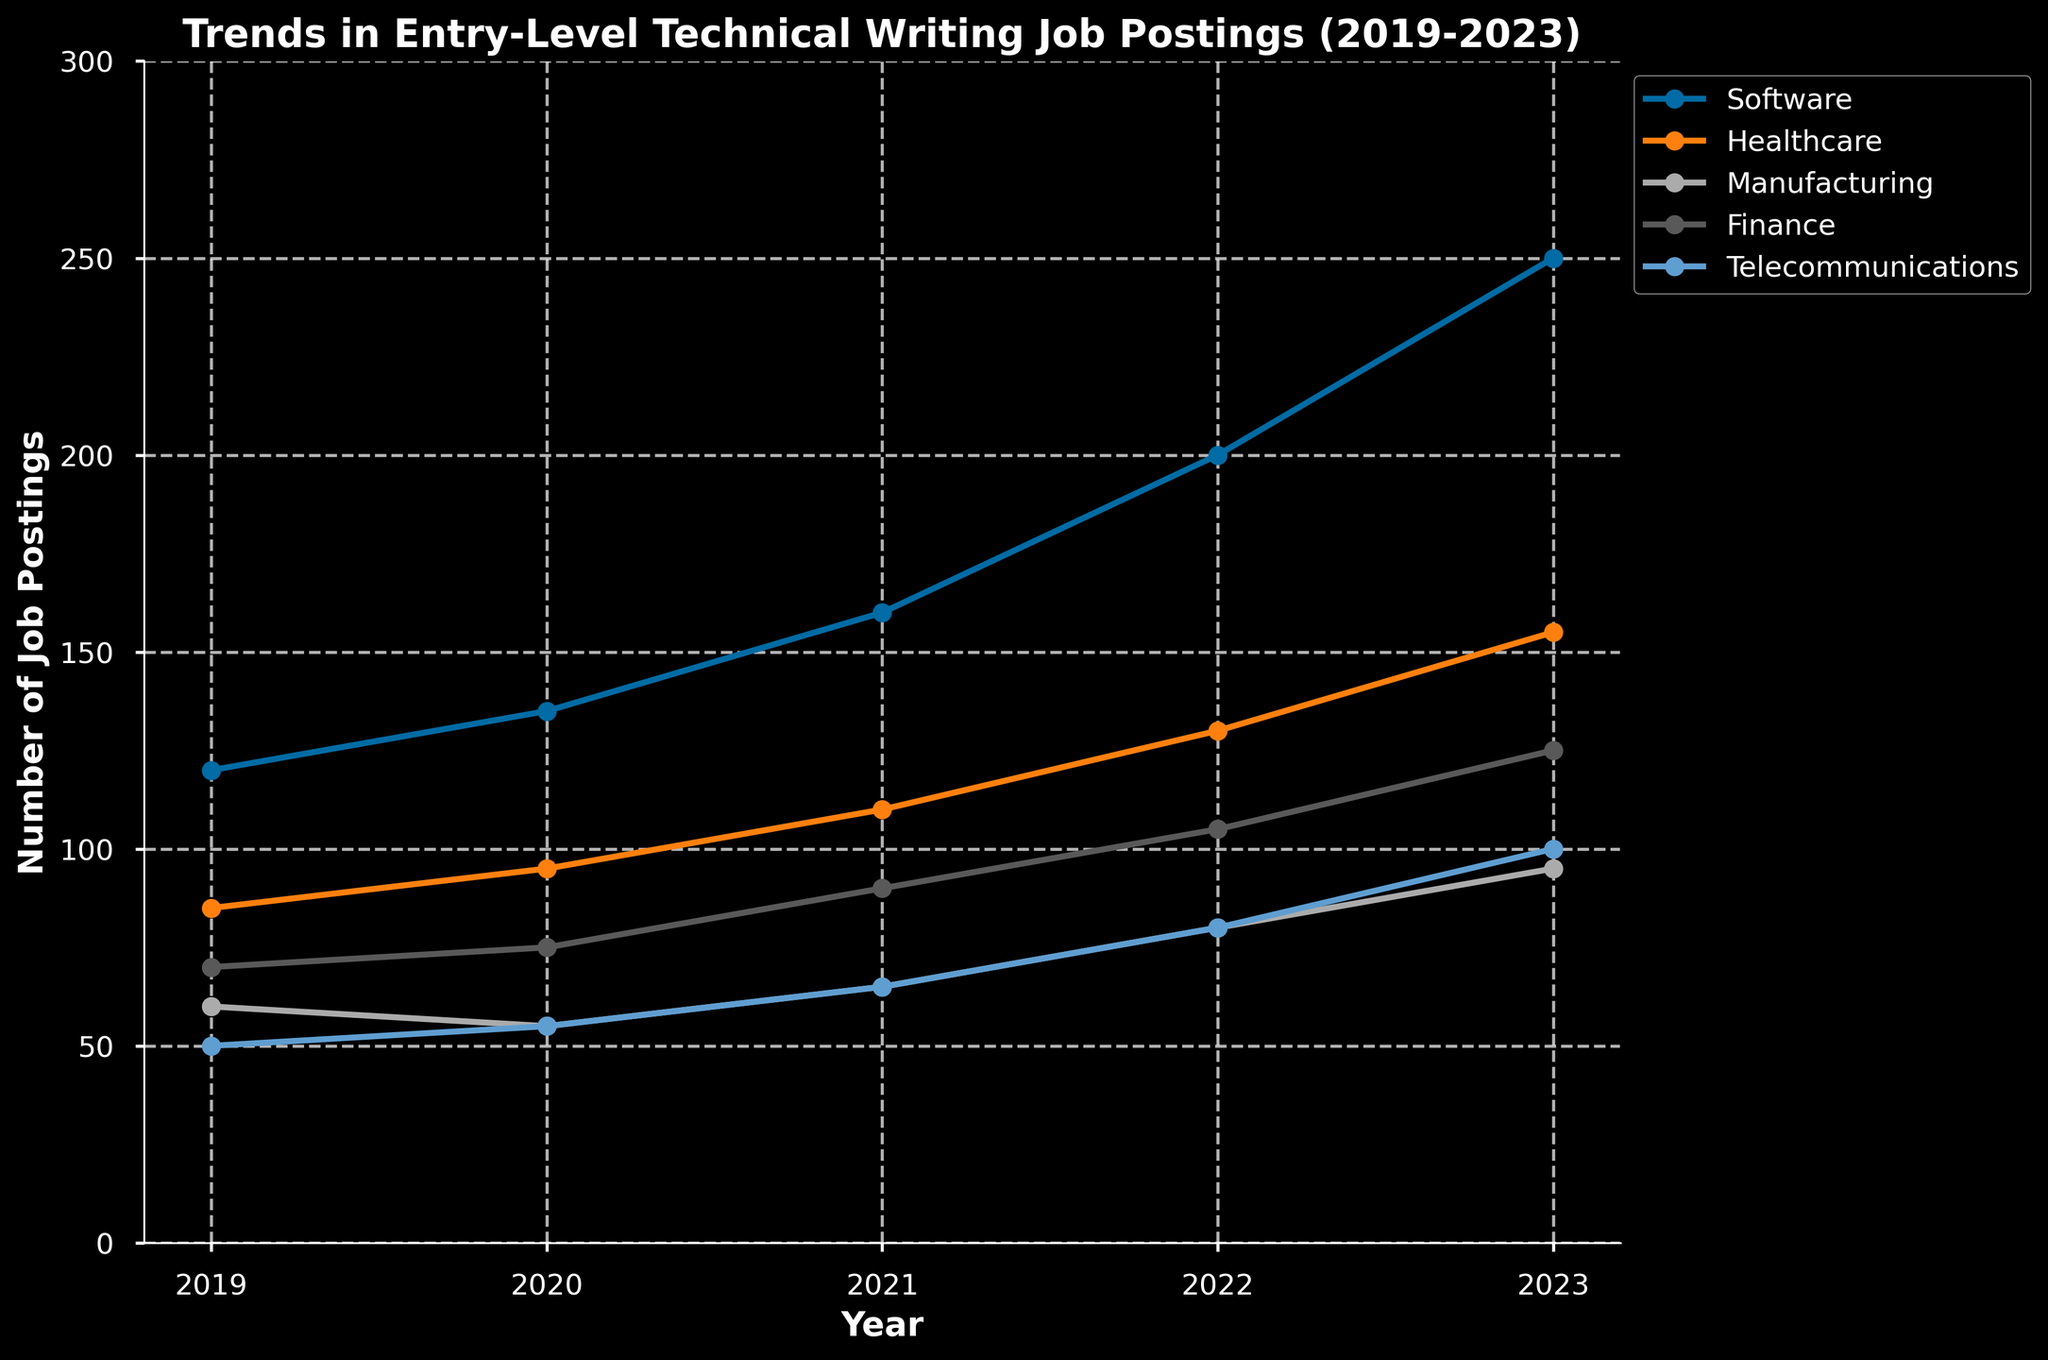What industry had the highest number of job postings in 2023? Looking at the figure, the line representing the Software industry reaches the highest point in 2023.
Answer: Software Which industry showed the most consistent growth over the 5 years? The Software industry shows a steady, consistent upward trend throughout the 5-year period. Other industries experience fluctuations.
Answer: Software How many job postings were there in total across all industries in 2021? Summing up the job postings for each industry in 2021 gives 160 (Software) + 110 (Healthcare) + 65 (Manufacturing) + 90 (Finance) + 65 (Telecommunications) = 490.
Answer: 490 What is the average number of job postings for the Manufacturing industry over the 5 years? Adding the job postings for the Manufacturing industry over 5 years (60 + 55 + 65 + 80 + 95) equals 355, and dividing by 5 gives an average of 71.
Answer: 71 In which year did Healthcare job postings surpass 100 for the first time? The figure shows Healthcare job postings exceeding 100 in 2021 for the first time (recording 110 postings).
Answer: 2021 Between 2020 and 2023, which industry had the greatest increase in job postings? Calculating the difference in job postings from 2020 to 2023: Software (250-135=115), Healthcare (155-95=60), Manufacturing (95-55=40), Finance (125-75=50), Telecommunications (100-55=45). Software had the greatest increase of 115.
Answer: Software Which industry had the least number of job postings in 2022? From the figure, the Telecommunications industry had the lowest point in 2022 with 80 job postings.
Answer: Telecommunications Was there any year where all the industries saw an increase in job postings compared to the previous year? By examining each year compared to the previous one, 2021, 2022, and 2023 show increases in all industries over the previous year.
Answer: Yes What's the total number of job postings for both Software and Healthcare industries in 2020? Summing the job postings for Software and Healthcare in 2020: 135 (Software) + 95 (Healthcare) = 230.
Answer: 230 By how much did Finance job postings change from 2019 to 2023? Subtracting Finance job postings in 2019 from 2023: 125 (2023) - 70 (2019) = 55.
Answer: 55 